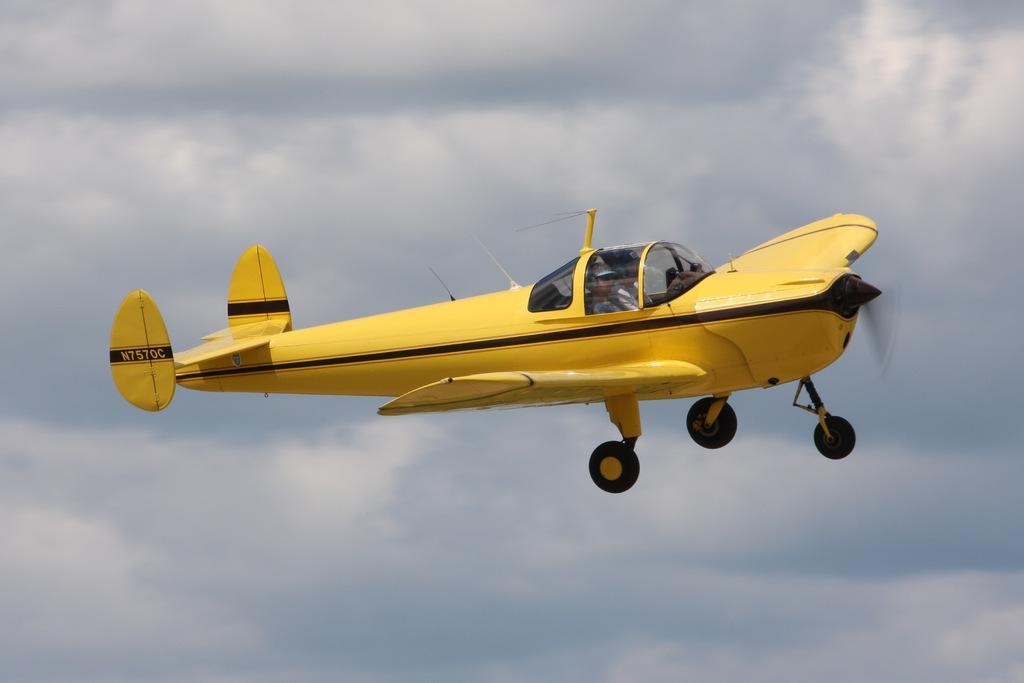Please provide a concise description of this image. In this image I can see an aeroplane which is in yellow and black color. The sky is in white and blue color. 